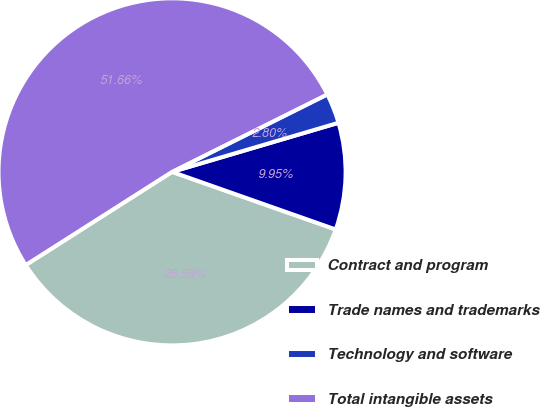Convert chart to OTSL. <chart><loc_0><loc_0><loc_500><loc_500><pie_chart><fcel>Contract and program<fcel>Trade names and trademarks<fcel>Technology and software<fcel>Total intangible assets<nl><fcel>35.59%<fcel>9.95%<fcel>2.8%<fcel>51.66%<nl></chart> 